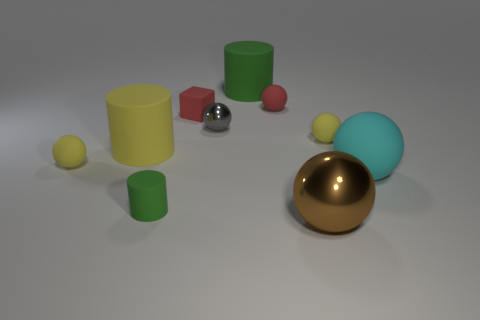What number of things are cyan objects behind the tiny green thing or big objects to the right of the small shiny sphere?
Make the answer very short. 3. The tiny shiny sphere has what color?
Your answer should be compact. Gray. What number of blocks are made of the same material as the big cyan sphere?
Offer a very short reply. 1. Are there more big red cylinders than small yellow matte objects?
Provide a short and direct response. No. What number of big yellow objects are behind the small matte sphere behind the small gray sphere?
Your answer should be very brief. 0. What number of things are either big cylinders right of the large yellow rubber cylinder or cyan metal cylinders?
Ensure brevity in your answer.  1. Is there a large brown rubber object that has the same shape as the large cyan matte object?
Ensure brevity in your answer.  No. There is a red matte thing that is on the left side of the green thing behind the large cyan object; what shape is it?
Offer a very short reply. Cube. How many cylinders are tiny green matte objects or large green matte objects?
Your answer should be compact. 2. What is the material of the big cylinder that is the same color as the tiny cylinder?
Your answer should be very brief. Rubber. 